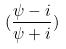<formula> <loc_0><loc_0><loc_500><loc_500>( \frac { \psi - i } { \psi + i } )</formula> 